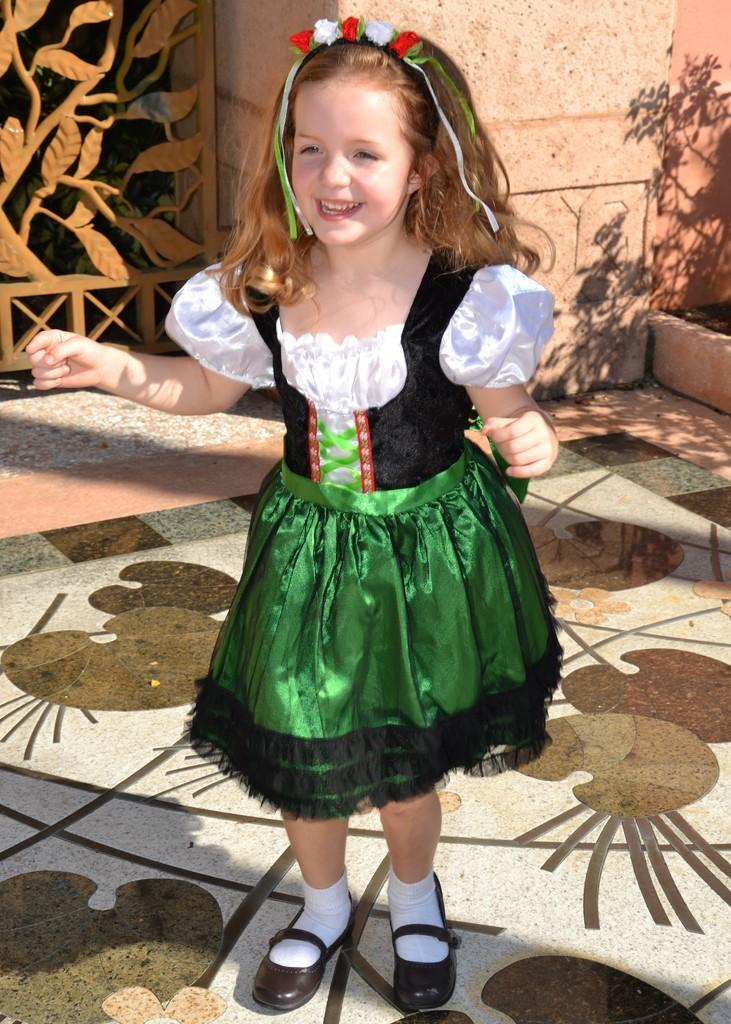Who is the main subject in the image? There is a girl in the image. What is the girl doing in the image? The girl is smiling in the image. Where is the girl located in the image? The girl is standing on the floor in the image. What can be seen in the background of the image? There is a shadow of a plant on the wall in the background of the image. What type of fork is the girl using to balance on her nose in the image? There is no fork present in the image, and the girl is not balancing anything on her nose. 